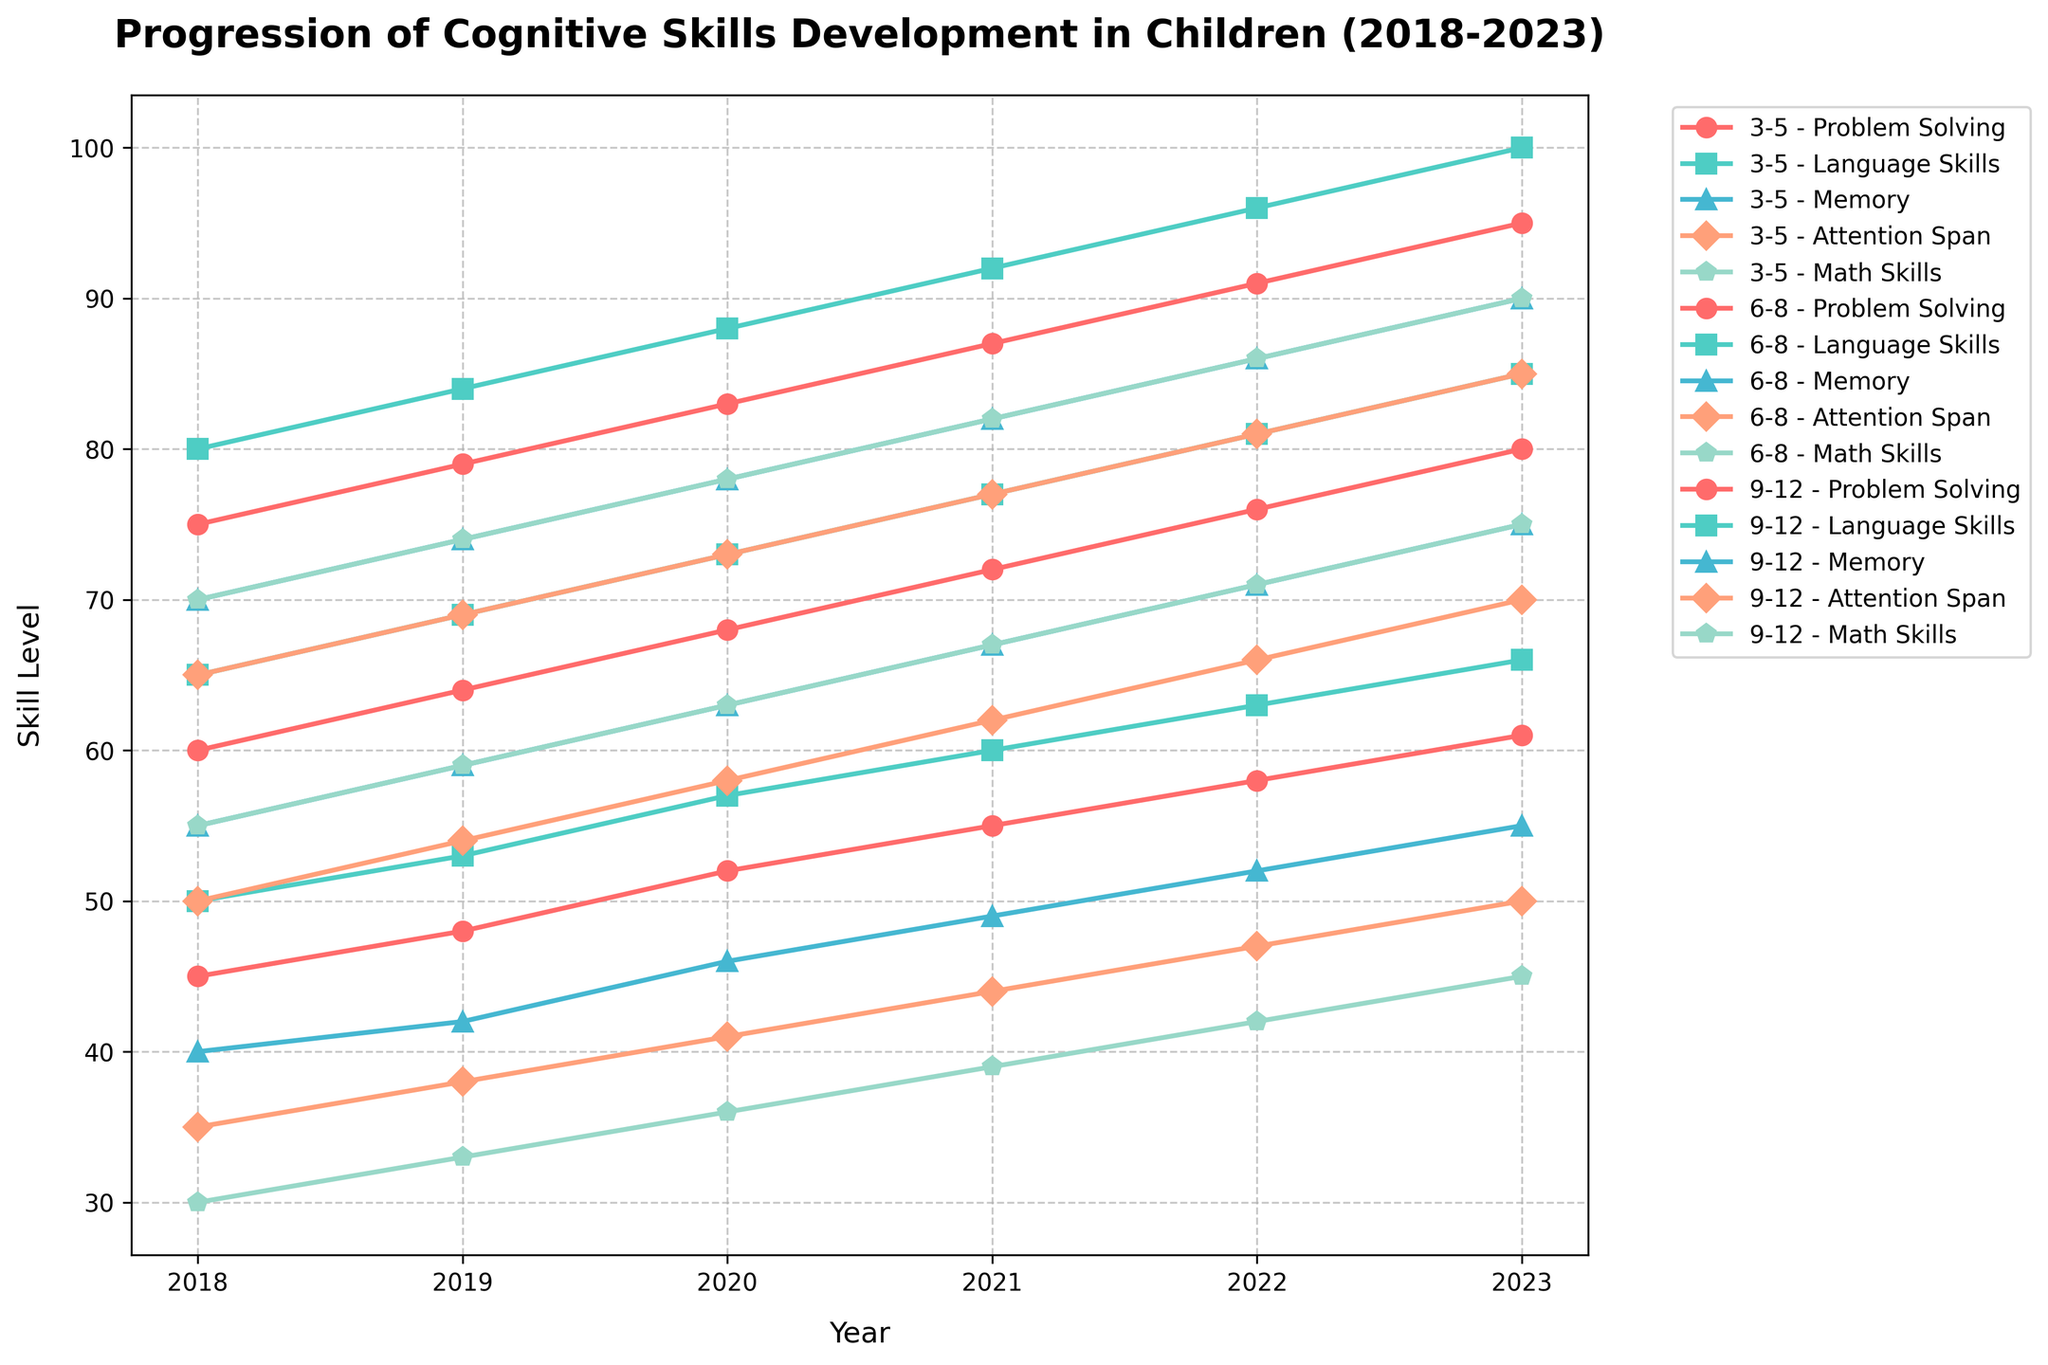What trend can be observed in the "Language Skills" for children aged 9-12 from 2018 to 2023? The "Language Skills" for children aged 9-12 show a consistent increase each year. Starting at 80 in 2018, it increases to 84 in 2019, 88 in 2020, 92 in 2021, 96 in 2022, and finally reaches 100 in 2023.
Answer: Consistent increase Between which years do children aged 6-8 exhibit the greatest increase in "Memory" skills? By comparing the differences in "Memory" skills between consecutive years for children aged 6-8, we see: 2018 to 2019 (4 units increase), 2019 to 2020 (4 units), 2020 to 2021 (4 units), 2021 to 2022 (4 units), and 2022 to 2023 (4 units). The increase is the same for all intervals.
Answer: 2018 to 2019, 2019 to 2020, 2020 to 2021, 2021 to 2022, 2022 to 2023 Which age group has the highest "Math Skills" level in 2023? By examining the "Math Skills" values for the year 2023, we find the following levels: children aged 3-5 have 45, children aged 6-8 have 75, and children aged 9-12 have 90. Thus, children aged 9-12 have the highest "Math Skills" in 2023.
Answer: 9-12 How does the growth in "Attention Span" between 2018 and 2023 compare among different age groups? For children aged 3-5, "Attention Span" grows from 35 to 50 (15 units), for children aged 6-8, it grows from 50 to 70 (20 units), and for children aged 9-12, it grows from 65 to 85 (20 units). Children aged 3-5 have the smallest increase, while both the 6-8 and 9-12 age groups show equal largest increases.
Answer: 6-8 and 9-12 have the largest growth, 3-5 has the smallest What is the difference in "Problem Solving" levels between children aged 3-5 and those aged 9-12 in 2021? In 2021, the "Problem Solving" level for children aged 3-5 is 55, while for children aged 9-12, it is 87. The difference is 87 - 55 = 32 units.
Answer: 32 units Which skill shows the least progression for children aged 3-5 from 2018 to 2023? By finding the changes from 2018 to 2023 for each skill: "Problem Solving" (61 - 45 = 16 units), "Language Skills" (66 - 50 = 16 units), "Memory" (55 - 40 = 15 units), "Attention Span" (50 - 35 = 15 units), "Math Skills" (45 - 30 = 15 units). "Memory", "Attention Span", and "Math Skills" all show the least progression, which is 15 units each.
Answer: Memory, Attention Span, Math Skills What color represents the "Problem Solving" skill in the figure? The "Problem Solving" skill is represented by the red lines. Each line for the respective age groups denoting "Problem Solving" is colored red.
Answer: Red 